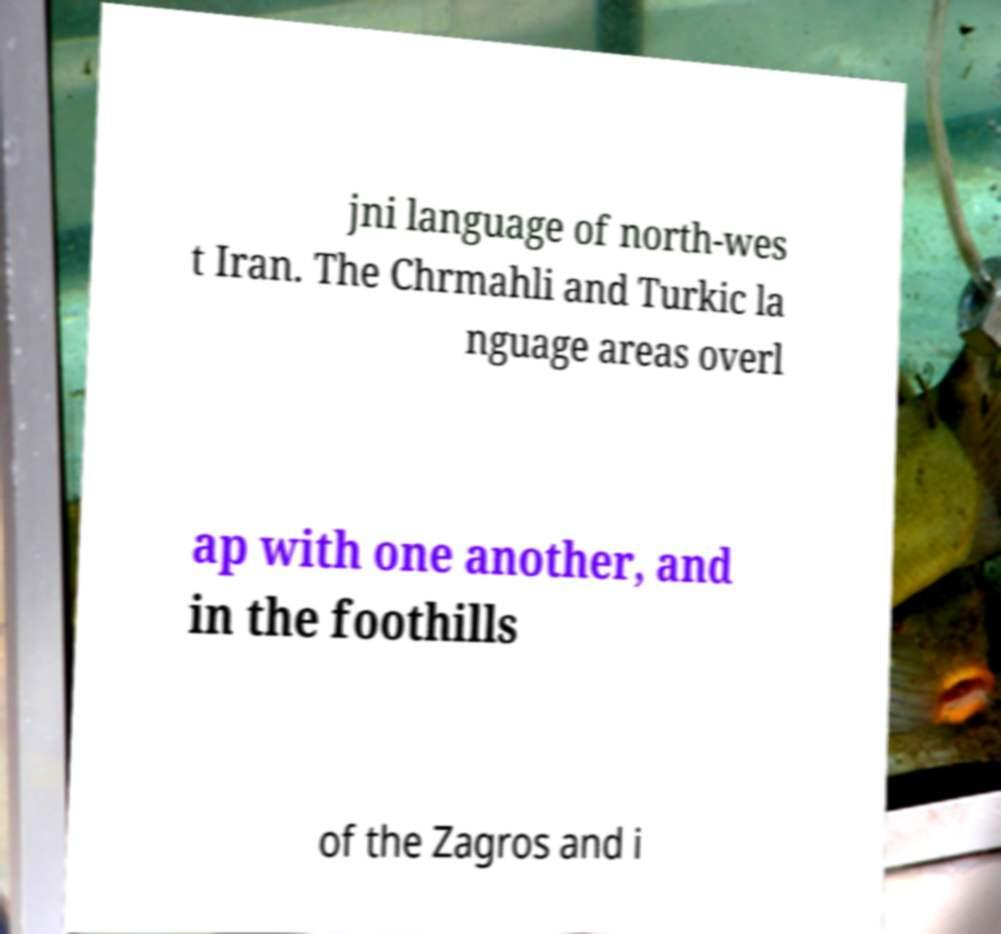Please read and relay the text visible in this image. What does it say? jni language of north-wes t Iran. The Chrmahli and Turkic la nguage areas overl ap with one another, and in the foothills of the Zagros and i 